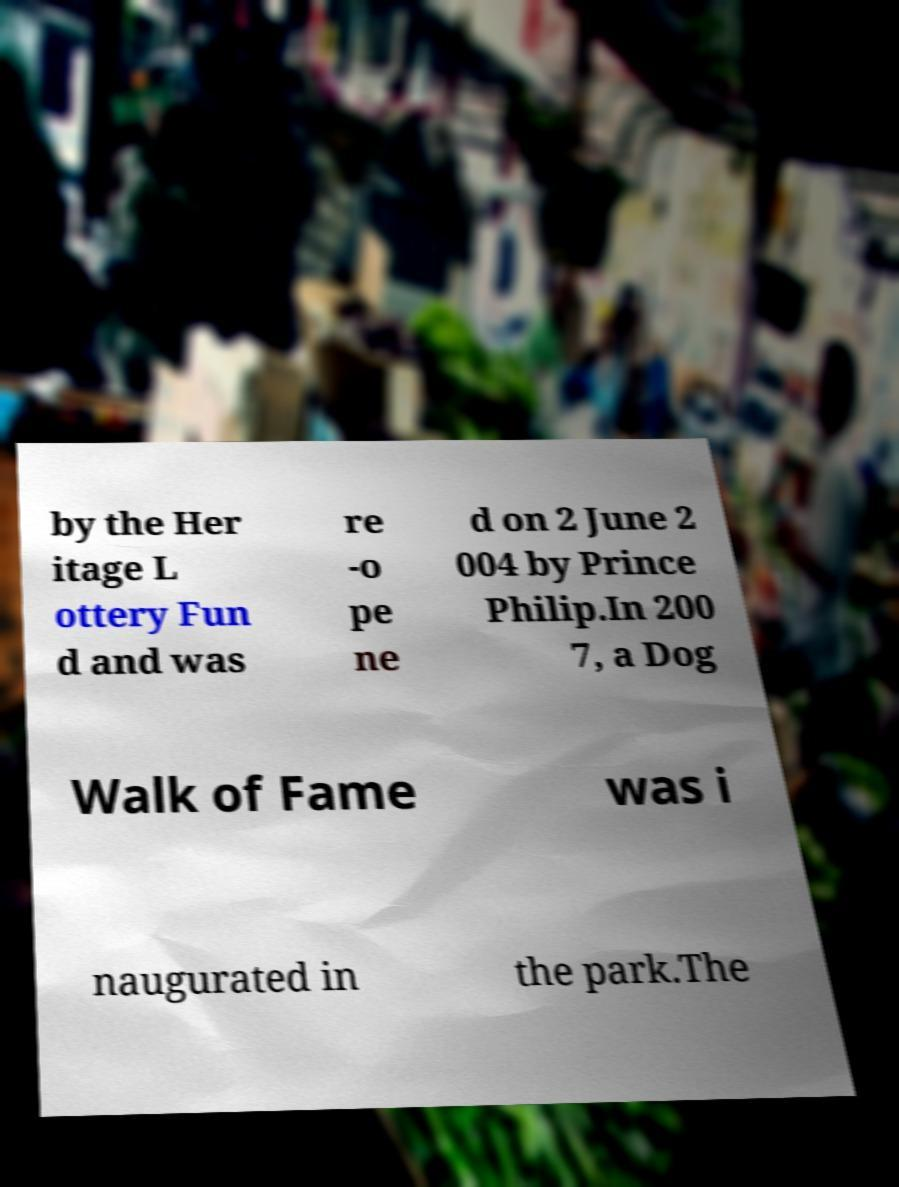There's text embedded in this image that I need extracted. Can you transcribe it verbatim? by the Her itage L ottery Fun d and was re -o pe ne d on 2 June 2 004 by Prince Philip.In 200 7, a Dog Walk of Fame was i naugurated in the park.The 